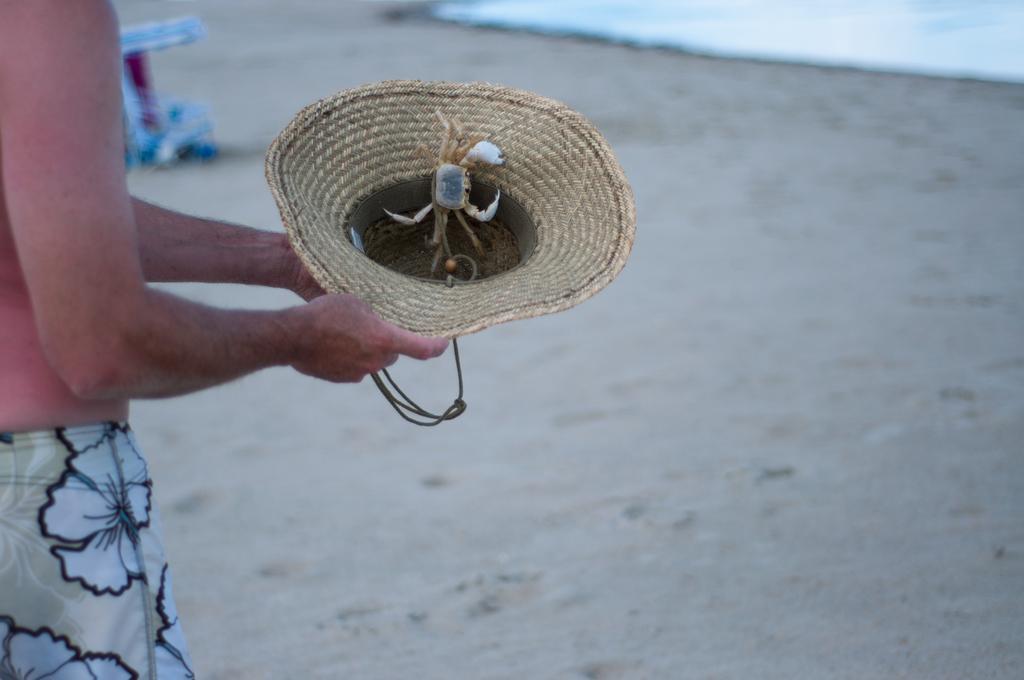Please provide a concise description of this image. In this image we can see a person standing on the sand and holding a hat and there is a crab in the hat and there is water and an object in the background. 